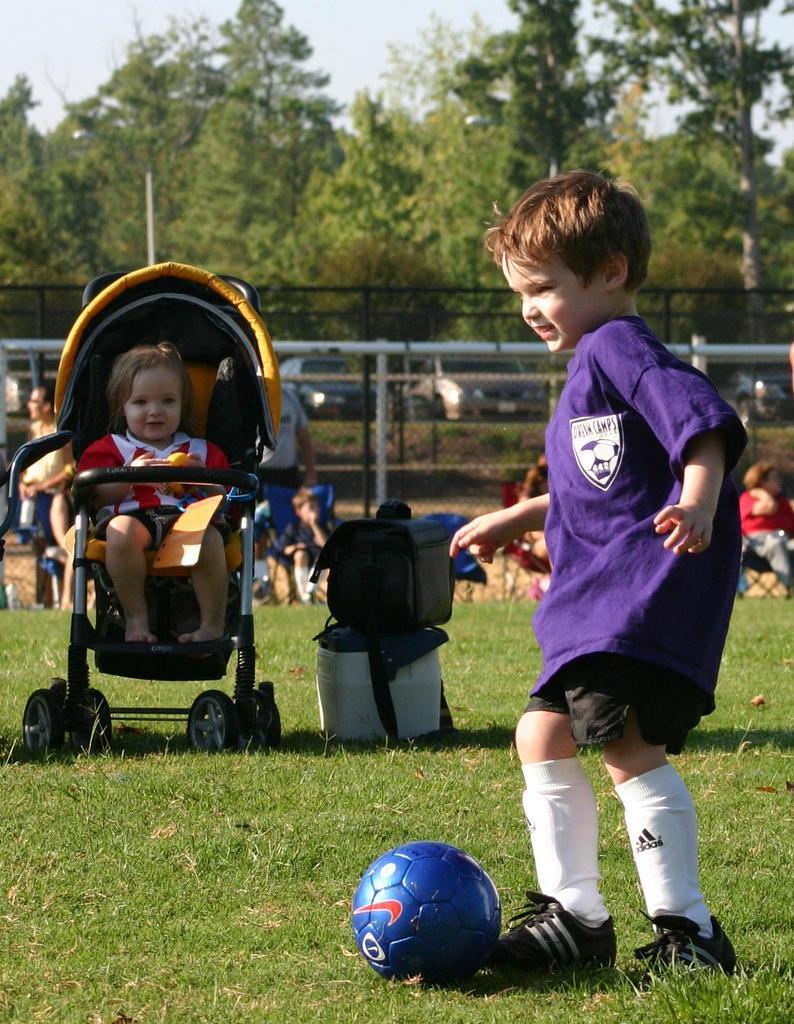Please provide a concise description of this image. This picture is clicked in a garden. Boy in blue t-shirt is kicking blue ball. Beside him, we see two bags and behind that, we see many people sitting on chair. We even see fence and behind that, we see many cars parked and we even see trees. On the left corner of the picture, we see a baby sitting on chair. 